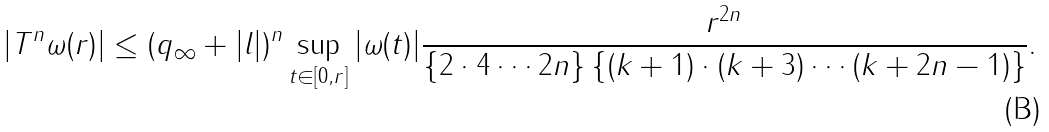<formula> <loc_0><loc_0><loc_500><loc_500>| T ^ { n } \omega ( r ) | \leq ( q _ { \infty } + | l | ) ^ { n } \sup _ { t \in [ 0 , r ] } | \omega ( t ) | \frac { r ^ { 2 n } } { \{ 2 \cdot 4 \cdots 2 n \} \, \{ ( k + 1 ) \cdot ( k + 3 ) \cdots ( k + 2 n - 1 ) \} } .</formula> 